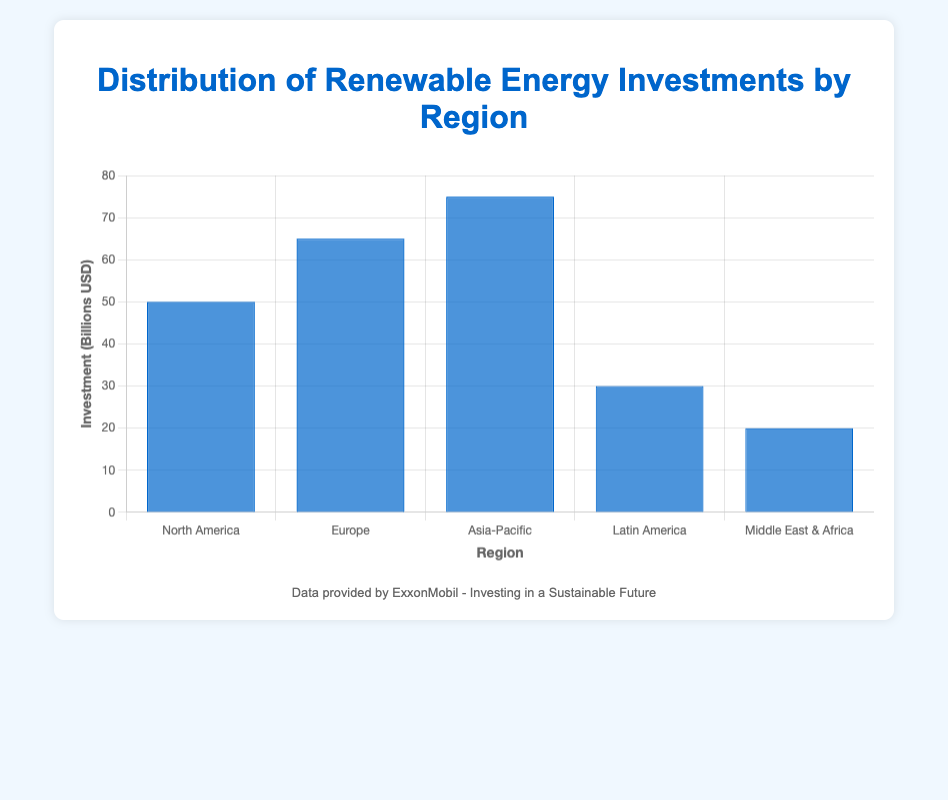What is the region with the highest investment in renewable energy? The region with the highest investment is identifiable by checking which blue bar is the tallest in the bar chart. The Asia-Pacific region has the tallest bar representing an investment of 75 billion USD.
Answer: Asia-Pacific Which region has the lowest investment, and what is the value? The region with the lowest investment is found by identifying the shortest blue bar in the bar chart. The Middle East & Africa region has the shortest bar, indicating an investment of 20 billion USD.
Answer: Middle East & Africa, 20 billion USD How much more does Europe invest in renewable energy compared to Latin America? To find the difference between Europe's and Latin America's investments, subtract Latin America's investment from Europe's investment. Europe invests 65 billion USD and Latin America invests 30 billion USD. Therefore, the difference is 65 - 30 = 35 billion USD.
Answer: 35 billion USD What is the average investment in renewable energy across all the regions? To compute the average investment, sum the investments of all regions and divide by the number of regions. The total investment is 50 + 65 + 75 + 30 + 20 = 240 billion USD. There are 5 regions: 240 / 5 = 48 billion USD.
Answer: 48 billion USD Which regions have investments greater than 50 billion USD? To determine the regions with investments greater than 50 billion USD, observe the heights of the bars and their corresponding values. The regions are Europe (65 billion USD) and Asia-Pacific (75 billion USD).
Answer: Europe, Asia-Pacific What is the total investment in renewable energy by North America and the Middle East & Africa combined? Sum the investments by North America and the Middle East & Africa. North America invests 50 billion USD and the Middle East & Africa invests 20 billion USD. Therefore, the total is 50 + 20 = 70 billion USD.
Answer: 70 billion USD How does the investment in renewable energy by North America compare to Europe and Latin America combined? First, calculate the total investment for Europe and Latin America by summing their investments: Europe (65 billion USD) + Latin America (30 billion USD) = 95 billion USD. North America's investment is 50 billion USD. Comparison shows that 50 billion USD is less than 95 billion USD.
Answer: Less What percentage of the total investment does the Asia-Pacific region hold? Calculate the percentage by dividing Asia-Pacific's investment by the total investment and multiplying by 100. The total investment is 240 billion USD, and Asia-Pacific's investment is 75 billion USD. (75 / 240) * 100 ≈ 31.25%.
Answer: 31.25% Which region has the median investment value, and what is that value? To find the median, organize investment amounts in ascending order: 20, 30, 50, 65, 75. The middle value is the median. The middle value is the third number, which is 50 billion USD, corresponding to North America.
Answer: North America, 50 billion USD 